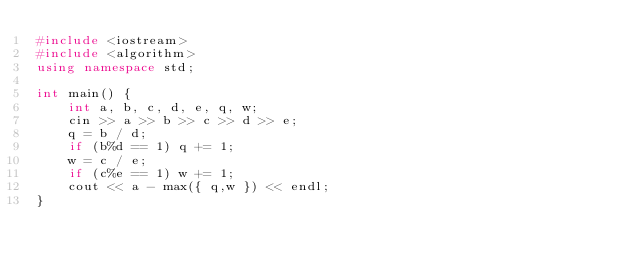<code> <loc_0><loc_0><loc_500><loc_500><_C++_>#include <iostream>
#include <algorithm>
using namespace std;

int main() {
	int a, b, c, d, e, q, w;
	cin >> a >> b >> c >> d >> e;
	q = b / d;
	if (b%d == 1) q += 1;
	w = c / e;
	if (c%e == 1) w += 1;
	cout << a - max({ q,w }) << endl;
}</code> 